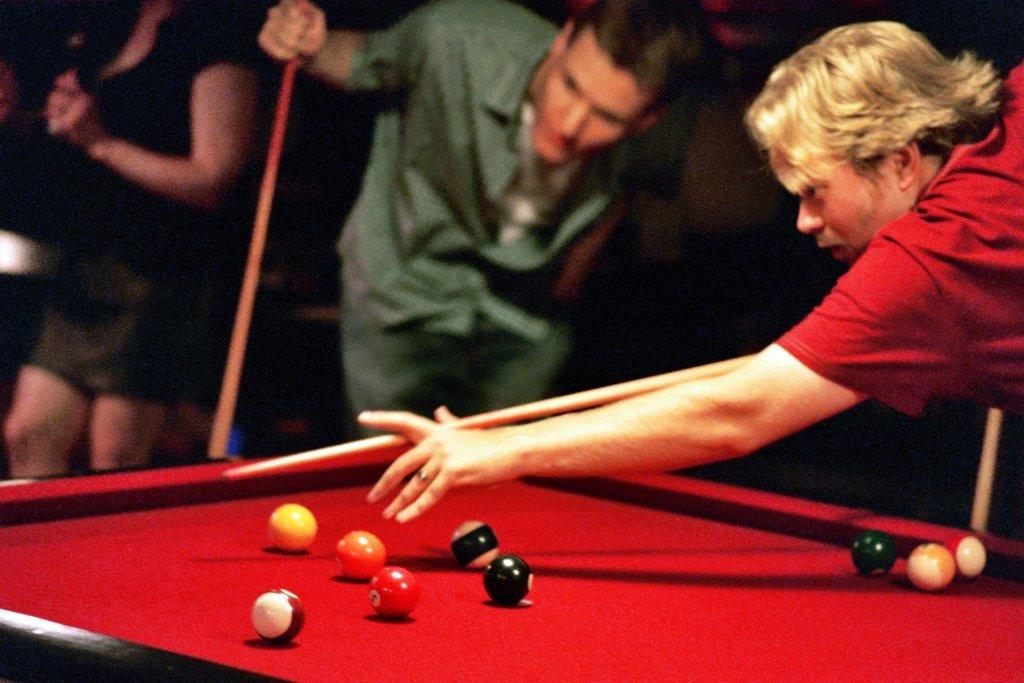What is the man in the image doing? The man is playing a snooker game. What is the surface on which the snooker game is being played? The snooker game is being played on a snooker board. Can you describe the setting in which the snooker game is taking place? There is a group of people in the background of the image. What type of impulse can be seen affecting the snooker balls in the image? There is no impulse affecting the snooker balls in the image; the man is playing the game by hitting the balls with a cue stick. Can you tell me how many pets are present in the image? There are no pets visible in the image. 